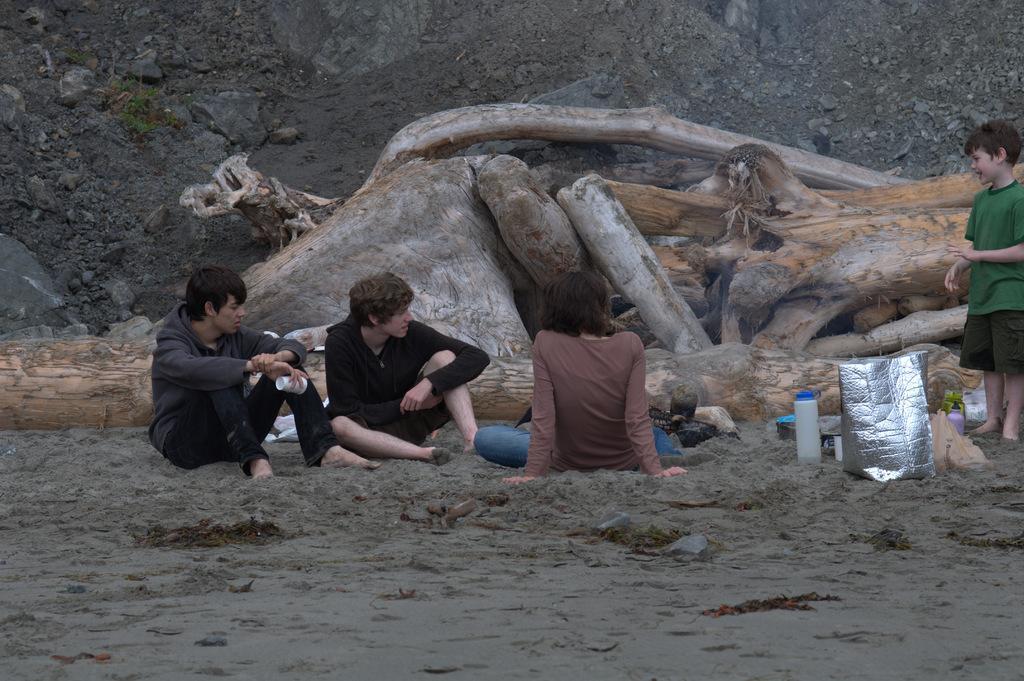Describe this image in one or two sentences. In this image we can see three people sitting. There is a cover, bottle and some objects placed on the ground. On the right there is a boy standing. In the background we can see logs and there are rocks. 